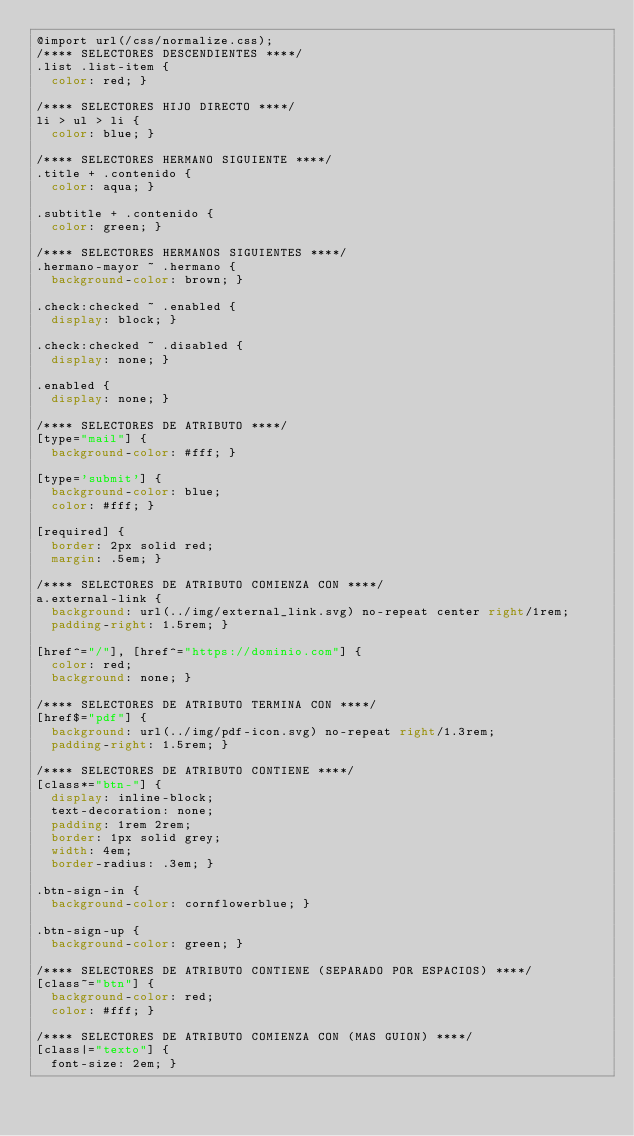<code> <loc_0><loc_0><loc_500><loc_500><_CSS_>@import url(/css/normalize.css);
/**** SELECTORES DESCENDIENTES ****/
.list .list-item {
  color: red; }

/**** SELECTORES HIJO DIRECTO ****/
li > ul > li {
  color: blue; }

/**** SELECTORES HERMANO SIGUIENTE ****/
.title + .contenido {
  color: aqua; }

.subtitle + .contenido {
  color: green; }

/**** SELECTORES HERMANOS SIGUIENTES ****/
.hermano-mayor ~ .hermano {
  background-color: brown; }

.check:checked ~ .enabled {
  display: block; }

.check:checked ~ .disabled {
  display: none; }

.enabled {
  display: none; }

/**** SELECTORES DE ATRIBUTO ****/
[type="mail"] {
  background-color: #fff; }

[type='submit'] {
  background-color: blue;
  color: #fff; }

[required] {
  border: 2px solid red;
  margin: .5em; }

/**** SELECTORES DE ATRIBUTO COMIENZA CON ****/
a.external-link {
  background: url(../img/external_link.svg) no-repeat center right/1rem;
  padding-right: 1.5rem; }

[href^="/"], [href^="https://dominio.com"] {
  color: red;
  background: none; }

/**** SELECTORES DE ATRIBUTO TERMINA CON ****/
[href$="pdf"] {
  background: url(../img/pdf-icon.svg) no-repeat right/1.3rem;
  padding-right: 1.5rem; }

/**** SELECTORES DE ATRIBUTO CONTIENE ****/
[class*="btn-"] {
  display: inline-block;
  text-decoration: none;
  padding: 1rem 2rem;
  border: 1px solid grey;
  width: 4em;
  border-radius: .3em; }

.btn-sign-in {
  background-color: cornflowerblue; }

.btn-sign-up {
  background-color: green; }

/**** SELECTORES DE ATRIBUTO CONTIENE (SEPARADO POR ESPACIOS) ****/
[class~="btn"] {
  background-color: red;
  color: #fff; }

/**** SELECTORES DE ATRIBUTO COMIENZA CON (MAS GUION) ****/
[class|="texto"] {
  font-size: 2em; }
</code> 